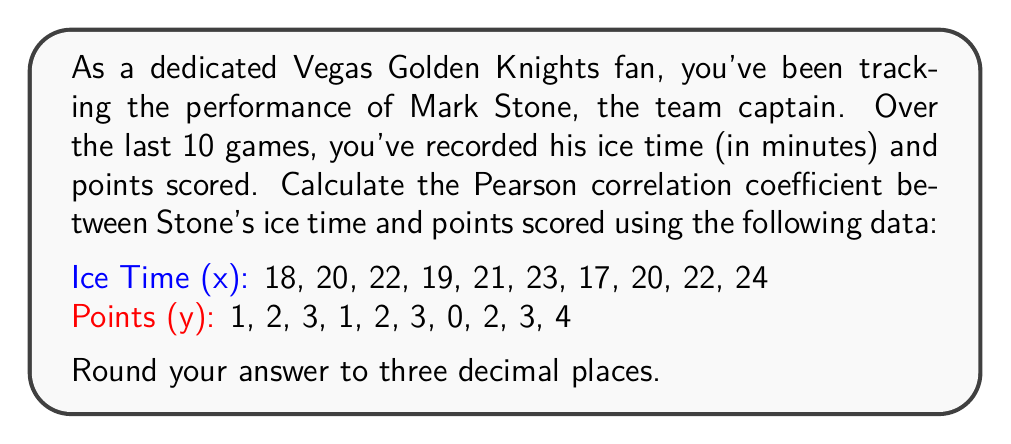Could you help me with this problem? To calculate the Pearson correlation coefficient (r), we'll use the formula:

$$ r = \frac{n\sum xy - \sum x \sum y}{\sqrt{[n\sum x^2 - (\sum x)^2][n\sum y^2 - (\sum y)^2]}} $$

Where n is the number of data points.

Step 1: Calculate the sums and squares:
n = 10
$\sum x = 206$
$\sum y = 21$
$\sum xy = 454$
$\sum x^2 = 4,290$
$\sum y^2 = 59$

Step 2: Calculate the numerator:
$n\sum xy - \sum x \sum y = 10(454) - 206(21) = 4,540 - 4,326 = 214$

Step 3: Calculate the denominator:
$[n\sum x^2 - (\sum x)^2] = 10(4,290) - 206^2 = 42,900 - 42,436 = 464$
$[n\sum y^2 - (\sum y)^2] = 10(59) - 21^2 = 590 - 441 = 149$

$\sqrt{464 \times 149} = \sqrt{69,136} = 262.938$

Step 4: Divide the numerator by the denominator:
$r = \frac{214}{262.938} = 0.8138$

Step 5: Round to three decimal places:
$r \approx 0.814$
Answer: 0.814 